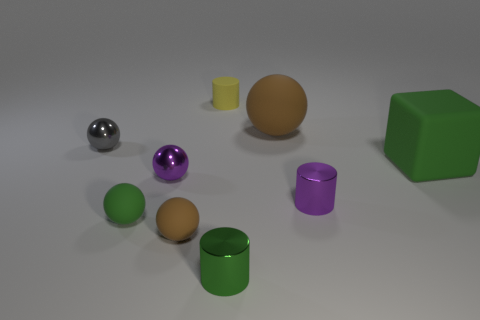Subtract 1 balls. How many balls are left? 4 Subtract all gray balls. How many balls are left? 4 Subtract all yellow balls. Subtract all yellow cubes. How many balls are left? 5 Add 1 green rubber things. How many objects exist? 10 Subtract all cylinders. How many objects are left? 6 Subtract all tiny yellow things. Subtract all tiny green metallic objects. How many objects are left? 7 Add 3 purple spheres. How many purple spheres are left? 4 Add 3 large blocks. How many large blocks exist? 4 Subtract 1 yellow cylinders. How many objects are left? 8 